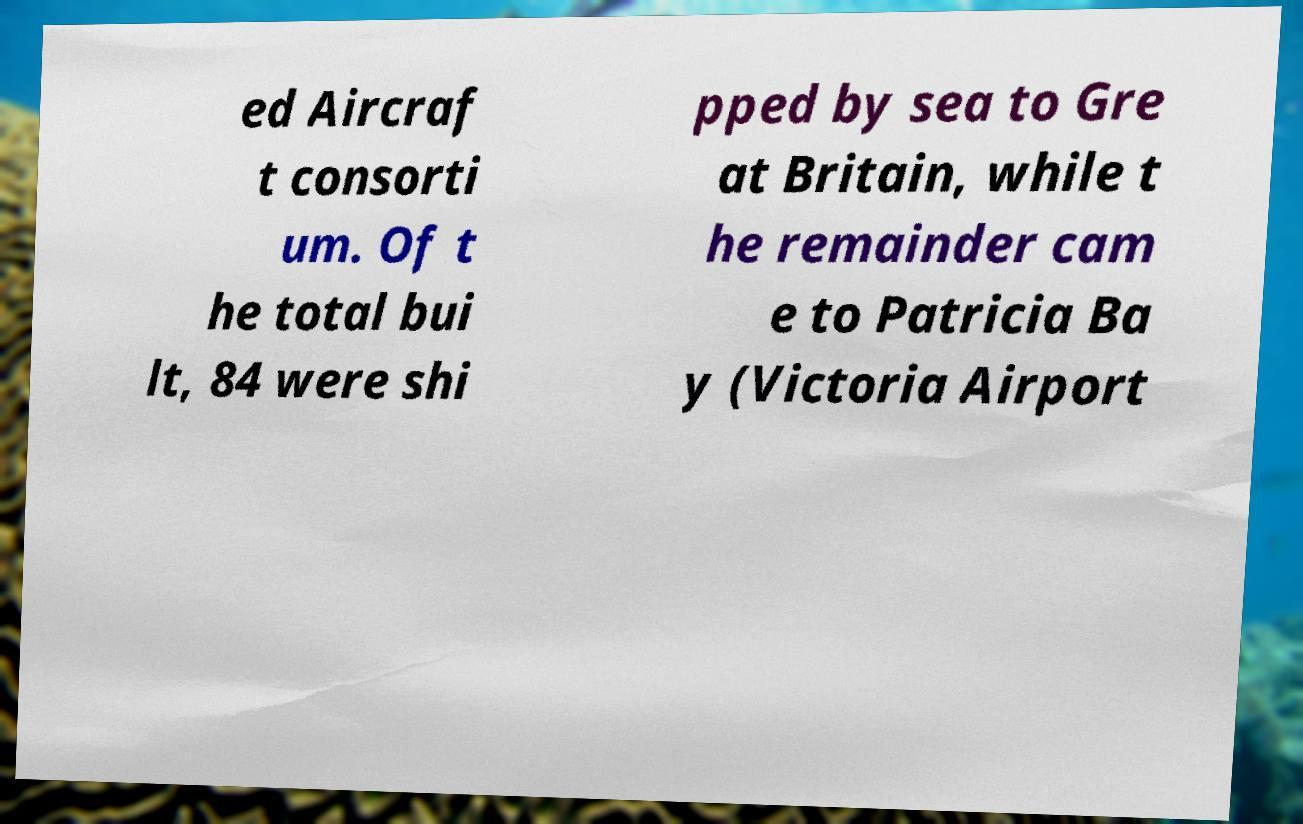I need the written content from this picture converted into text. Can you do that? ed Aircraf t consorti um. Of t he total bui lt, 84 were shi pped by sea to Gre at Britain, while t he remainder cam e to Patricia Ba y (Victoria Airport 